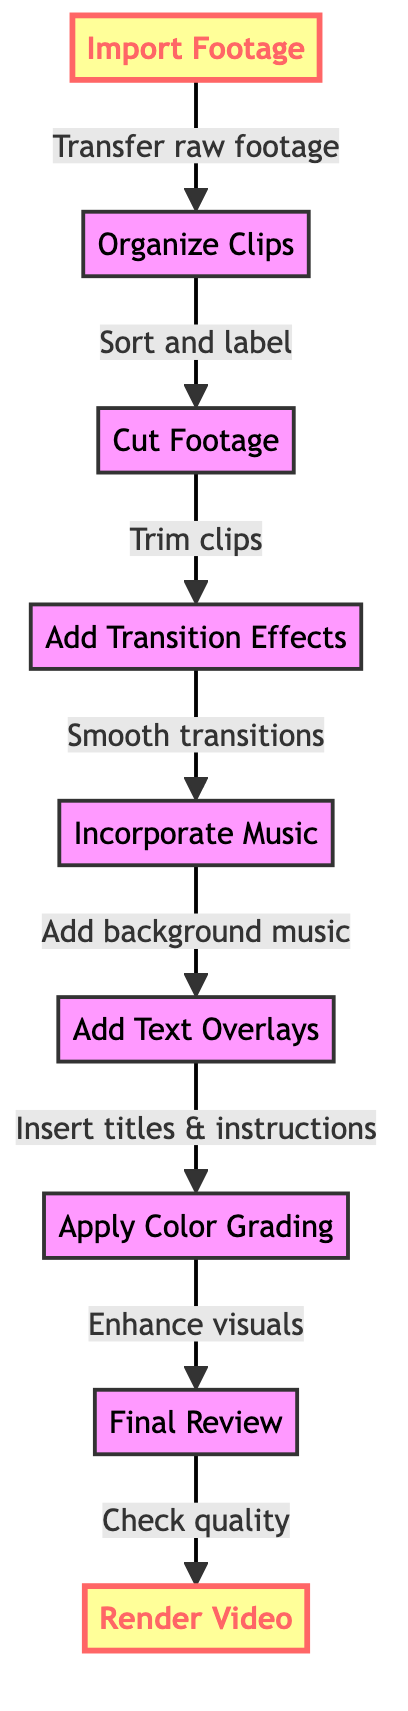What is the first step in the editing process? The diagram clearly shows the first node, labeled "Import Footage," indicating that this is the initial step one must take in the editing process.
Answer: Import Footage How many total steps are in the flow chart? The flow chart lists a total of nine distinct steps, from "Import Footage" to "Render Video." Counting each node confirms this total.
Answer: 9 What follows "Cut Footage" in the editing sequence? The flow chart shows that after "Cut Footage," the next step is "Add Transition Effects," indicating a sequential flow.
Answer: Add Transition Effects Which step involves adding background music? According to the flow chart, "Incorporate Music" is the specific step where background music is added to the footage during the editing process.
Answer: Incorporate Music What is the final step in the flow chart? The diagram shows that the last step is "Render Video," indicating that this is the concluding action taken after all editing has been completed.
Answer: Render Video Which techniques need to be performed before "Apply Color Grading"? The flow chart indicates that the steps "Cut Footage," "Add Transition Effects," "Incorporate Music," and "Add Text Overlays" must all be performed before reaching "Apply Color Grading."
Answer: Cut Footage, Add Transition Effects, Incorporate Music, Add Text Overlays What two steps involve viewer engagement? The flow chart shows that "Add Text Overlays" and "Incorporate Music" both focus on enhancing viewer engagement, making these the steps related to audience interaction.
Answer: Add Text Overlays, Incorporate Music How is the visual flow maintained between clips? The relevant step, "Add Transition Effects," is specifically designated to incorporate smooth transitions, ensuring a seamless visual flow between different clips.
Answer: Add Transition Effects Which step requires a review of quality? The flow chart states that "Final Review" is the step focused on examining the quality, continuity, and pacing of the edited video.
Answer: Final Review 